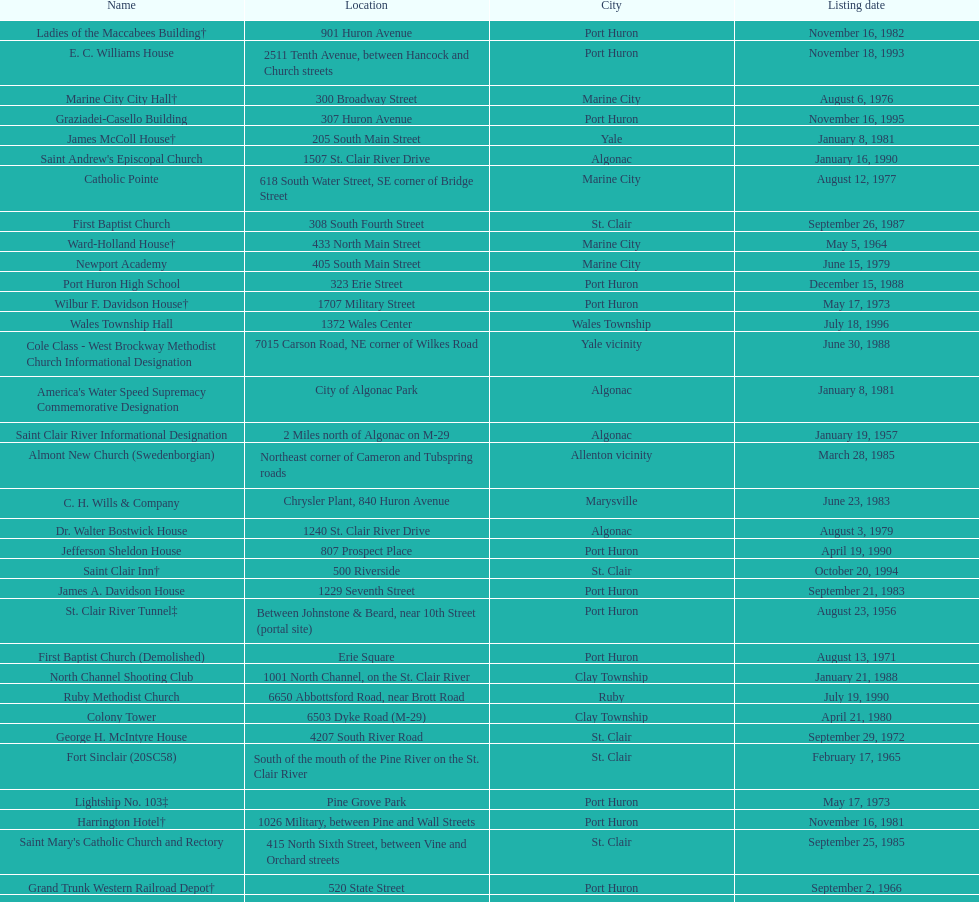Which city is home to the greatest number of historic sites, existing or demolished? Port Huron. 